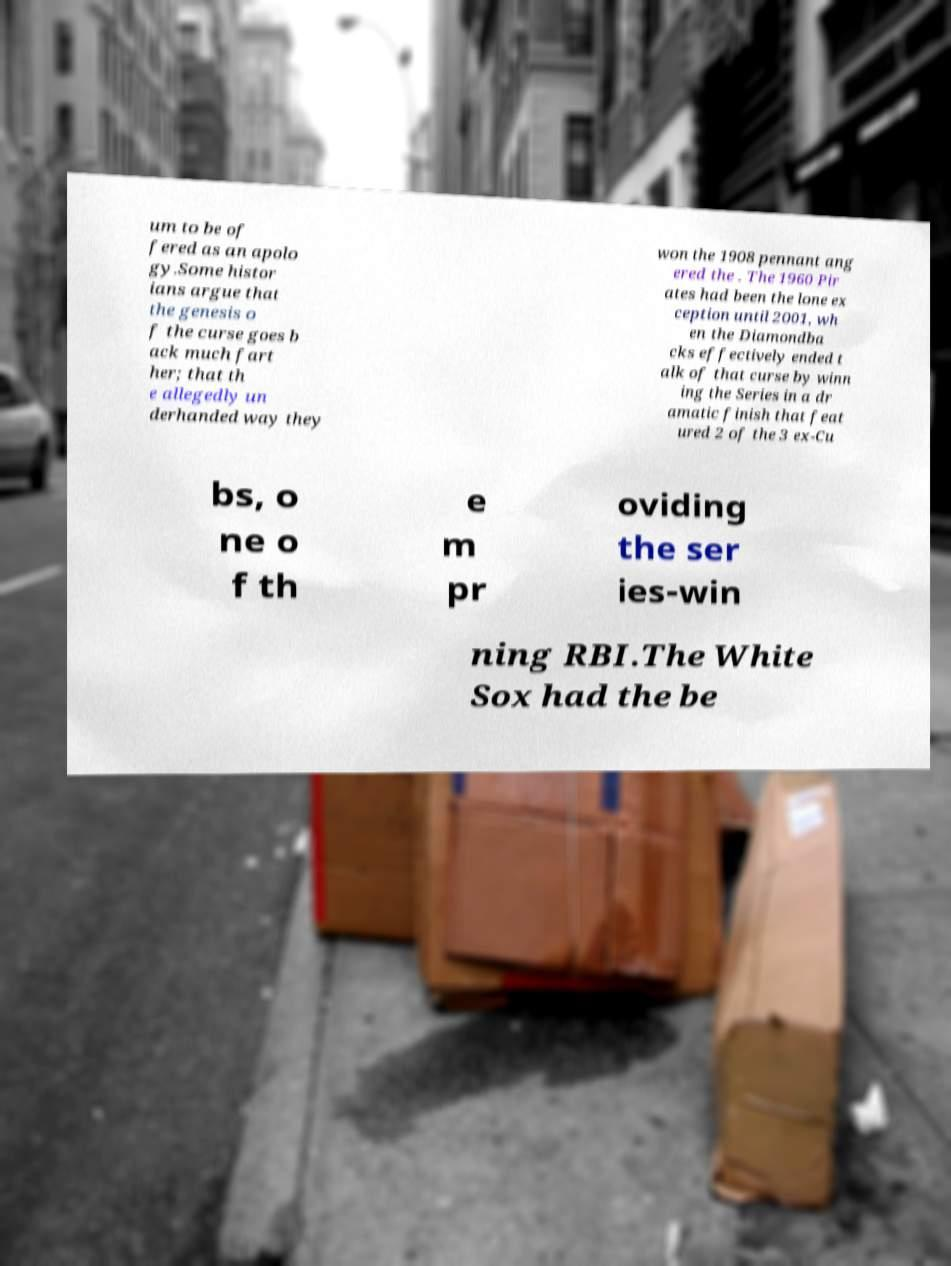Please read and relay the text visible in this image. What does it say? um to be of fered as an apolo gy.Some histor ians argue that the genesis o f the curse goes b ack much fart her; that th e allegedly un derhanded way they won the 1908 pennant ang ered the . The 1960 Pir ates had been the lone ex ception until 2001, wh en the Diamondba cks effectively ended t alk of that curse by winn ing the Series in a dr amatic finish that feat ured 2 of the 3 ex-Cu bs, o ne o f th e m pr oviding the ser ies-win ning RBI.The White Sox had the be 